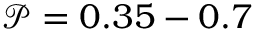Convert formula to latex. <formula><loc_0><loc_0><loc_500><loc_500>\mathcal { P } = 0 . 3 5 - 0 . 7</formula> 